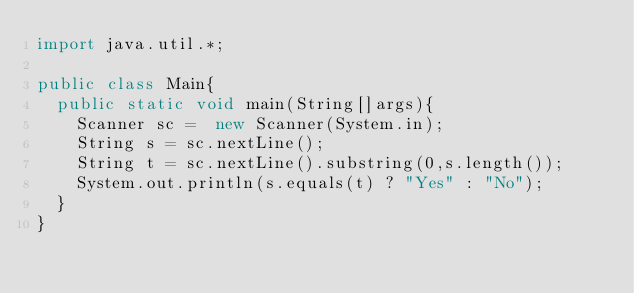Convert code to text. <code><loc_0><loc_0><loc_500><loc_500><_Java_>import java.util.*;
 
public class Main{
  public static void main(String[]args){
    Scanner sc =  new Scanner(System.in);
    String s = sc.nextLine();
    String t = sc.nextLine().substring(0,s.length());
    System.out.println(s.equals(t) ? "Yes" : "No");
  }
}</code> 